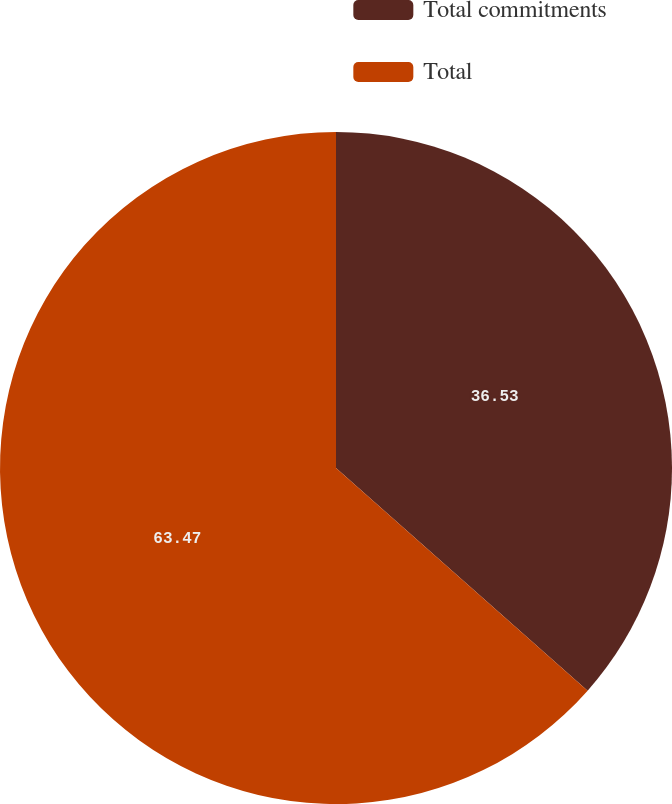<chart> <loc_0><loc_0><loc_500><loc_500><pie_chart><fcel>Total commitments<fcel>Total<nl><fcel>36.53%<fcel>63.47%<nl></chart> 